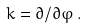<formula> <loc_0><loc_0><loc_500><loc_500>k = \partial / \partial \varphi \, .</formula> 